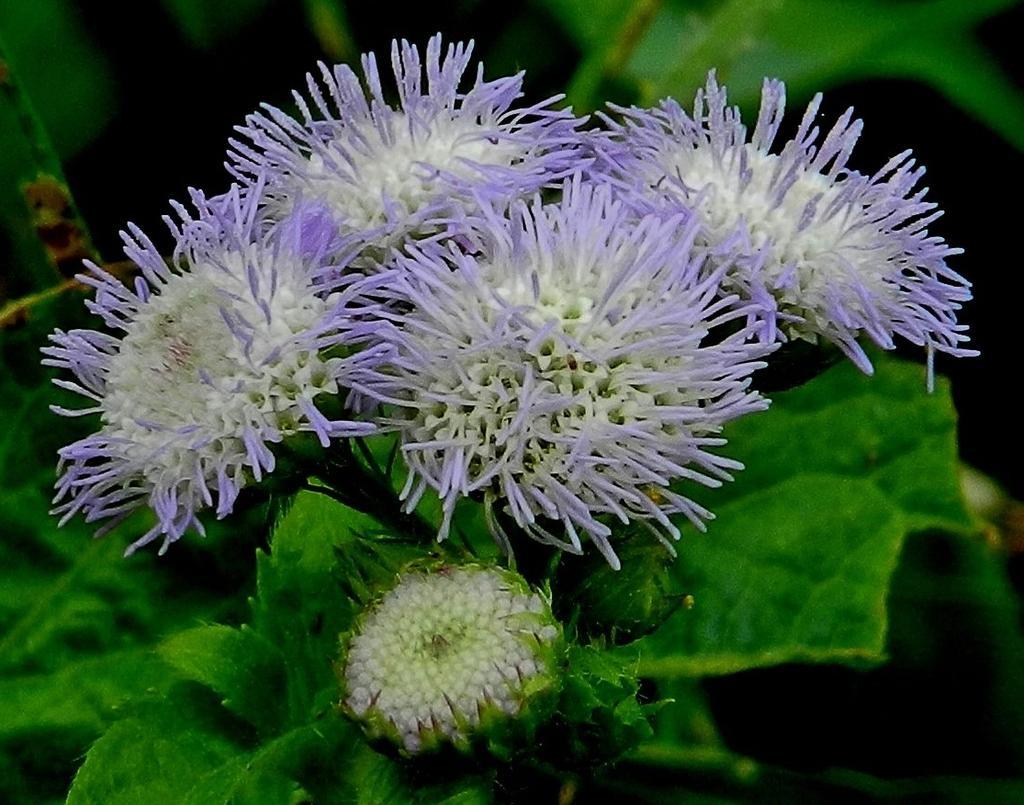How would you summarize this image in a sentence or two? In the picture I can see some flowers which are in violet color and there are some leaves which are in green color. 